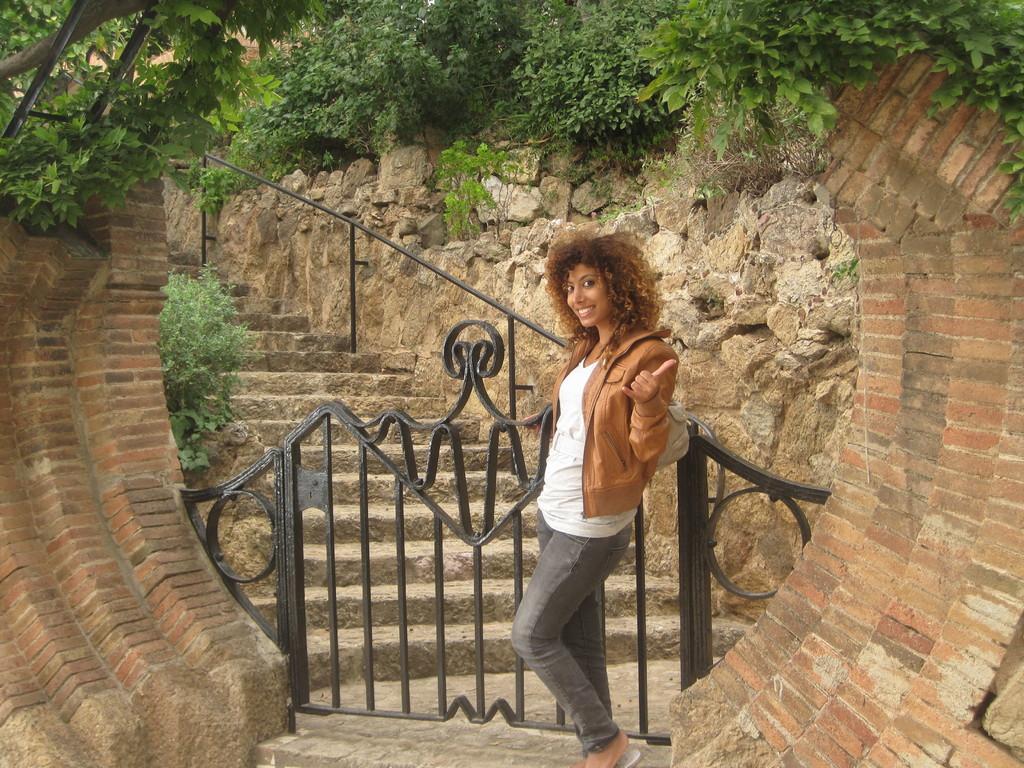Could you give a brief overview of what you see in this image? In the middle of this image, there is a woman in white color T-shirt, smiling and showing a symbol with a hand. Beside her, there is a gate and an arch which is having a plant on the top. In the background, there are steps which are having a fence and there are plants and stones on a hill 